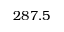Convert formula to latex. <formula><loc_0><loc_0><loc_500><loc_500>2 8 7 . 5</formula> 